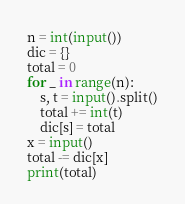Convert code to text. <code><loc_0><loc_0><loc_500><loc_500><_Python_>n = int(input())
dic = {}
total = 0
for _ in range(n):
    s, t = input().split()
    total += int(t)
    dic[s] = total
x = input()
total -= dic[x]
print(total)</code> 